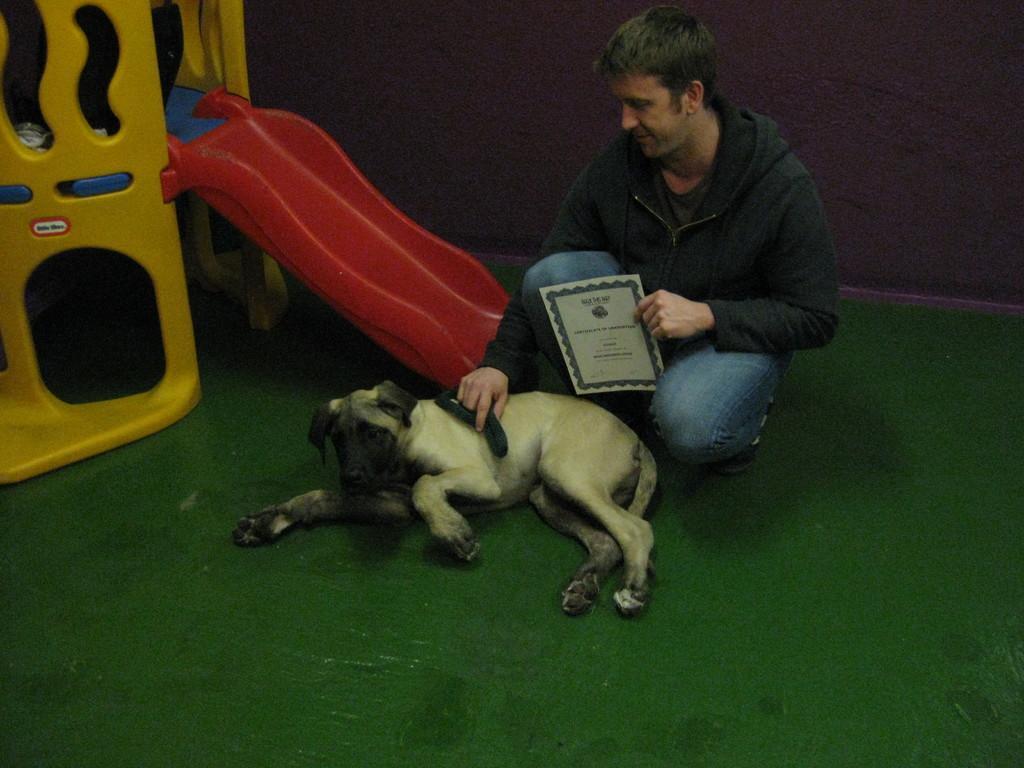In one or two sentences, can you explain what this image depicts? In the middle of this image, there is a person, holding a certificate with a hand, placing an object on a dog, which is lying on a green color mat. On the left side, there is a yellow color shelter of the dog. And the background is dark in color. 